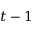Convert formula to latex. <formula><loc_0><loc_0><loc_500><loc_500>t - 1</formula> 